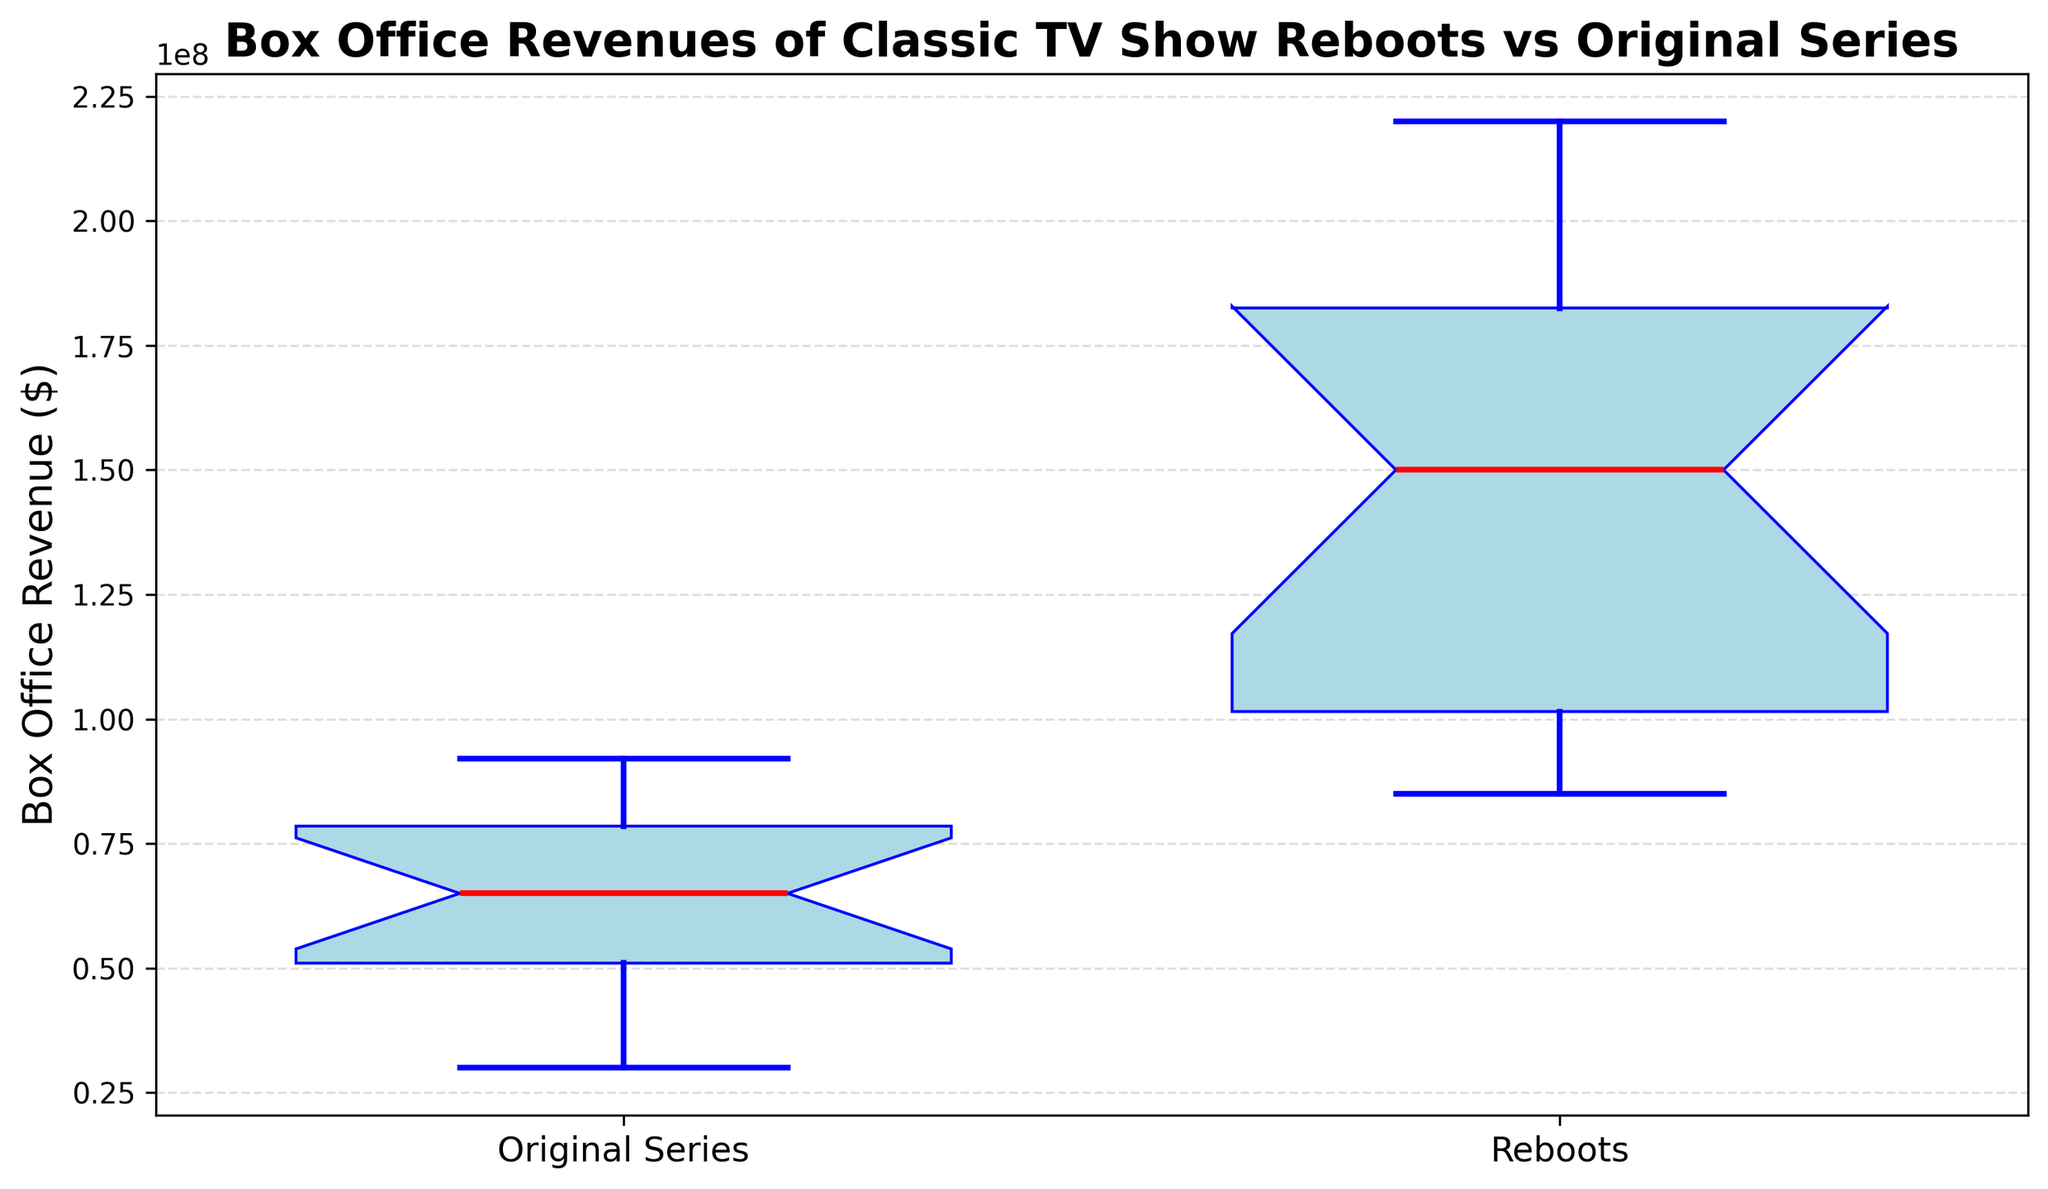What's the median value of the box office revenue for the original series? Look at the middle line inside the box for the Original Series; it represents the median.
Answer: $65,000,000 Which group has the higher median box office revenue, Original Series or Reboots? Compare the median lines of both boxplots. The Reboots' median is higher than the Original Series’.
Answer: Reboots What is the approximate difference between the median box office revenues of Reboots and Original Series? Subtract the median of the Original Series from the median of the Reboots. Reboots' median appears around $140,000,000 and Original Series at $65,000,000. The difference is $140,000,000 - $65,000,000.
Answer: $75,000,000 Which group shows a wider spread of box office revenues? Compare the lengths of the boxes and whiskers; the longer they are, the wider the spread. The Reboots have a wider spread.
Answer: Reboots What is the maximum box office revenue reported for Reboots? Look at the top whisker of the Reboots boxplot to determine the highest point.
Answer: $220,000,000 How does the interquartile range (IQR) of the Reboots compare to the Original Series? The IQR is the range of the middle 50% of data, seen as the height of the box. Reboots have a taller box compared to the Original Series, indicating a larger IQR.
Answer: Larger for Reboots Are there any outliers in the box office revenues for Original Series? Outliers are usually marked with different symbols like '+' outside the whiskers. Check if there are such markers around the Original Series plot.
Answer: No Between Original Series and Reboots, which has the higher third quartile (Q3) value? The third quartile is the top edge of the box. The Reboots' Q3 is higher than the Original Series'.
Answer: Reboots What can be inferred about the consistency of box office revenues between Original Series and Reboots? The consistency can be inferred from the spread and IQR of the plot. Original Series shows a narrower spread and smaller IQR compared to Reboots, indicating more consistent revenues.
Answer: Original Series are more consistent 